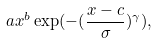Convert formula to latex. <formula><loc_0><loc_0><loc_500><loc_500>a x ^ { b } \exp ( { - ( \frac { x - c } { \sigma } ) ^ { \gamma } } ) ,</formula> 